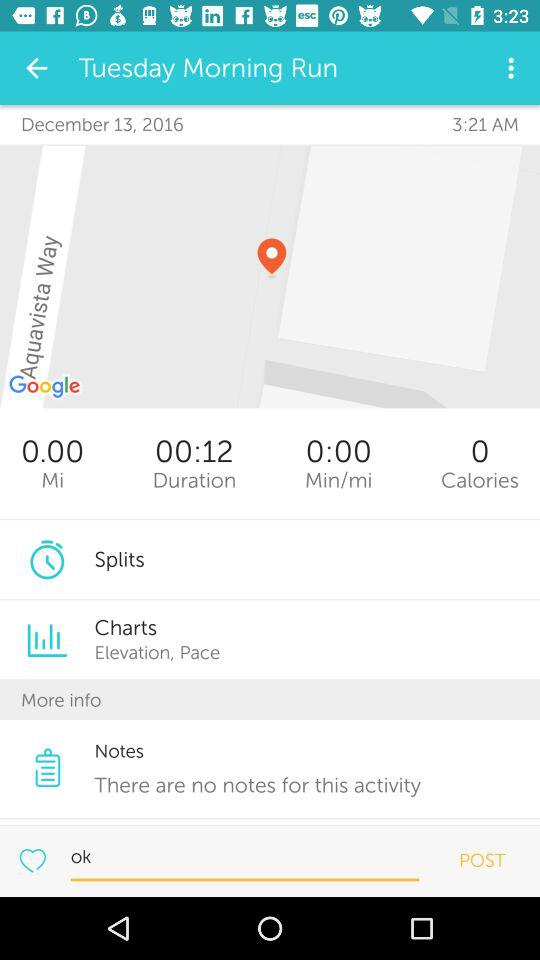What duration is shown on the screen? The duration is 00:12. 